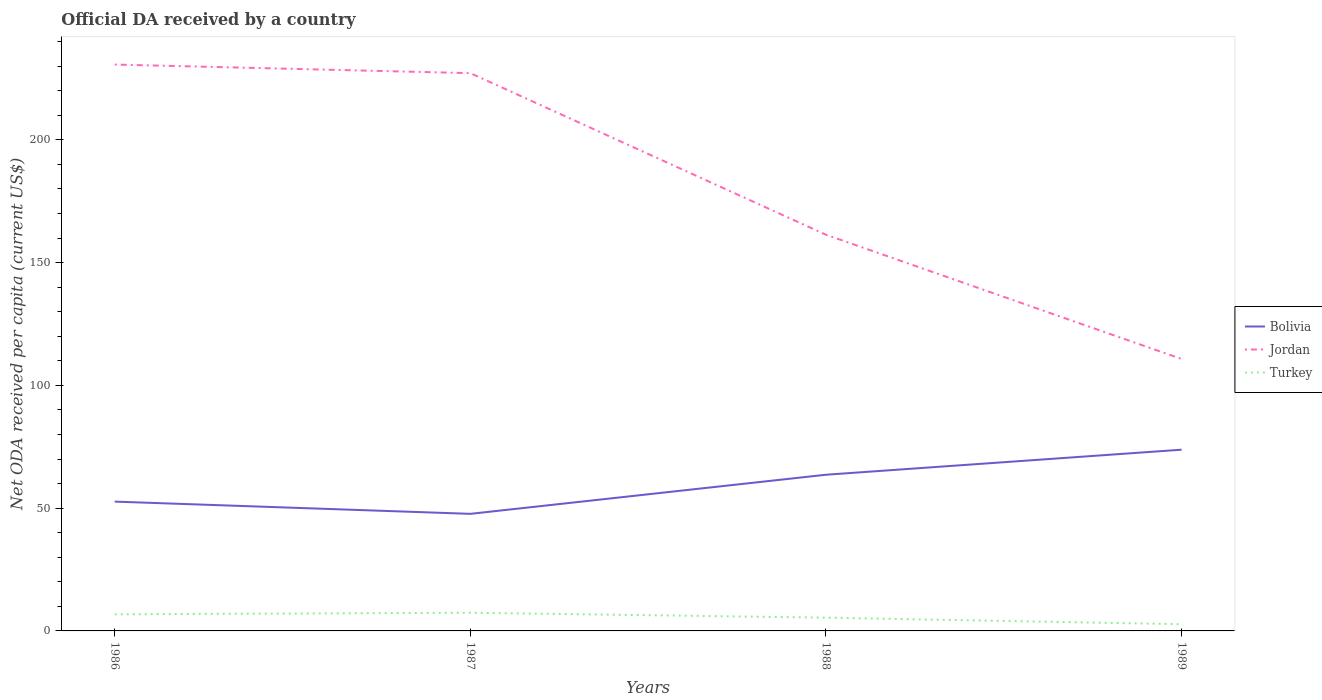Is the number of lines equal to the number of legend labels?
Offer a very short reply. Yes. Across all years, what is the maximum ODA received in in Turkey?
Offer a very short reply. 2.73. What is the total ODA received in in Bolivia in the graph?
Your answer should be compact. -26.13. What is the difference between the highest and the second highest ODA received in in Bolivia?
Provide a short and direct response. 26.13. What is the difference between the highest and the lowest ODA received in in Turkey?
Your answer should be compact. 2. How many years are there in the graph?
Keep it short and to the point. 4. What is the difference between two consecutive major ticks on the Y-axis?
Give a very brief answer. 50. Does the graph contain grids?
Give a very brief answer. No. Where does the legend appear in the graph?
Make the answer very short. Center right. How are the legend labels stacked?
Your answer should be very brief. Vertical. What is the title of the graph?
Offer a terse response. Official DA received by a country. What is the label or title of the Y-axis?
Your response must be concise. Net ODA received per capita (current US$). What is the Net ODA received per capita (current US$) of Bolivia in 1986?
Offer a very short reply. 52.66. What is the Net ODA received per capita (current US$) of Jordan in 1986?
Provide a succinct answer. 230.66. What is the Net ODA received per capita (current US$) of Turkey in 1986?
Make the answer very short. 6.77. What is the Net ODA received per capita (current US$) in Bolivia in 1987?
Offer a terse response. 47.68. What is the Net ODA received per capita (current US$) in Jordan in 1987?
Ensure brevity in your answer.  227.16. What is the Net ODA received per capita (current US$) in Turkey in 1987?
Ensure brevity in your answer.  7.4. What is the Net ODA received per capita (current US$) in Bolivia in 1988?
Offer a very short reply. 63.61. What is the Net ODA received per capita (current US$) in Jordan in 1988?
Offer a very short reply. 161.36. What is the Net ODA received per capita (current US$) in Turkey in 1988?
Provide a succinct answer. 5.41. What is the Net ODA received per capita (current US$) in Bolivia in 1989?
Make the answer very short. 73.81. What is the Net ODA received per capita (current US$) of Jordan in 1989?
Offer a terse response. 110.76. What is the Net ODA received per capita (current US$) in Turkey in 1989?
Provide a short and direct response. 2.73. Across all years, what is the maximum Net ODA received per capita (current US$) in Bolivia?
Provide a short and direct response. 73.81. Across all years, what is the maximum Net ODA received per capita (current US$) of Jordan?
Give a very brief answer. 230.66. Across all years, what is the maximum Net ODA received per capita (current US$) in Turkey?
Provide a short and direct response. 7.4. Across all years, what is the minimum Net ODA received per capita (current US$) of Bolivia?
Offer a very short reply. 47.68. Across all years, what is the minimum Net ODA received per capita (current US$) of Jordan?
Give a very brief answer. 110.76. Across all years, what is the minimum Net ODA received per capita (current US$) in Turkey?
Offer a very short reply. 2.73. What is the total Net ODA received per capita (current US$) in Bolivia in the graph?
Offer a terse response. 237.76. What is the total Net ODA received per capita (current US$) of Jordan in the graph?
Provide a succinct answer. 729.93. What is the total Net ODA received per capita (current US$) in Turkey in the graph?
Provide a succinct answer. 22.31. What is the difference between the Net ODA received per capita (current US$) of Bolivia in 1986 and that in 1987?
Ensure brevity in your answer.  4.98. What is the difference between the Net ODA received per capita (current US$) in Jordan in 1986 and that in 1987?
Ensure brevity in your answer.  3.5. What is the difference between the Net ODA received per capita (current US$) of Turkey in 1986 and that in 1987?
Offer a terse response. -0.63. What is the difference between the Net ODA received per capita (current US$) in Bolivia in 1986 and that in 1988?
Your answer should be very brief. -10.95. What is the difference between the Net ODA received per capita (current US$) in Jordan in 1986 and that in 1988?
Offer a very short reply. 69.3. What is the difference between the Net ODA received per capita (current US$) of Turkey in 1986 and that in 1988?
Your answer should be very brief. 1.37. What is the difference between the Net ODA received per capita (current US$) of Bolivia in 1986 and that in 1989?
Give a very brief answer. -21.15. What is the difference between the Net ODA received per capita (current US$) of Jordan in 1986 and that in 1989?
Give a very brief answer. 119.9. What is the difference between the Net ODA received per capita (current US$) of Turkey in 1986 and that in 1989?
Offer a terse response. 4.04. What is the difference between the Net ODA received per capita (current US$) in Bolivia in 1987 and that in 1988?
Give a very brief answer. -15.93. What is the difference between the Net ODA received per capita (current US$) in Jordan in 1987 and that in 1988?
Keep it short and to the point. 65.8. What is the difference between the Net ODA received per capita (current US$) in Turkey in 1987 and that in 1988?
Offer a terse response. 2. What is the difference between the Net ODA received per capita (current US$) in Bolivia in 1987 and that in 1989?
Provide a succinct answer. -26.13. What is the difference between the Net ODA received per capita (current US$) in Jordan in 1987 and that in 1989?
Ensure brevity in your answer.  116.4. What is the difference between the Net ODA received per capita (current US$) of Turkey in 1987 and that in 1989?
Offer a very short reply. 4.67. What is the difference between the Net ODA received per capita (current US$) in Bolivia in 1988 and that in 1989?
Provide a short and direct response. -10.2. What is the difference between the Net ODA received per capita (current US$) of Jordan in 1988 and that in 1989?
Make the answer very short. 50.6. What is the difference between the Net ODA received per capita (current US$) in Turkey in 1988 and that in 1989?
Keep it short and to the point. 2.67. What is the difference between the Net ODA received per capita (current US$) in Bolivia in 1986 and the Net ODA received per capita (current US$) in Jordan in 1987?
Your response must be concise. -174.49. What is the difference between the Net ODA received per capita (current US$) of Bolivia in 1986 and the Net ODA received per capita (current US$) of Turkey in 1987?
Your answer should be compact. 45.26. What is the difference between the Net ODA received per capita (current US$) of Jordan in 1986 and the Net ODA received per capita (current US$) of Turkey in 1987?
Provide a short and direct response. 223.25. What is the difference between the Net ODA received per capita (current US$) of Bolivia in 1986 and the Net ODA received per capita (current US$) of Jordan in 1988?
Offer a terse response. -108.69. What is the difference between the Net ODA received per capita (current US$) in Bolivia in 1986 and the Net ODA received per capita (current US$) in Turkey in 1988?
Provide a short and direct response. 47.26. What is the difference between the Net ODA received per capita (current US$) of Jordan in 1986 and the Net ODA received per capita (current US$) of Turkey in 1988?
Your answer should be very brief. 225.25. What is the difference between the Net ODA received per capita (current US$) in Bolivia in 1986 and the Net ODA received per capita (current US$) in Jordan in 1989?
Keep it short and to the point. -58.09. What is the difference between the Net ODA received per capita (current US$) of Bolivia in 1986 and the Net ODA received per capita (current US$) of Turkey in 1989?
Give a very brief answer. 49.93. What is the difference between the Net ODA received per capita (current US$) in Jordan in 1986 and the Net ODA received per capita (current US$) in Turkey in 1989?
Provide a succinct answer. 227.93. What is the difference between the Net ODA received per capita (current US$) in Bolivia in 1987 and the Net ODA received per capita (current US$) in Jordan in 1988?
Give a very brief answer. -113.68. What is the difference between the Net ODA received per capita (current US$) of Bolivia in 1987 and the Net ODA received per capita (current US$) of Turkey in 1988?
Make the answer very short. 42.27. What is the difference between the Net ODA received per capita (current US$) of Jordan in 1987 and the Net ODA received per capita (current US$) of Turkey in 1988?
Keep it short and to the point. 221.75. What is the difference between the Net ODA received per capita (current US$) of Bolivia in 1987 and the Net ODA received per capita (current US$) of Jordan in 1989?
Provide a succinct answer. -63.08. What is the difference between the Net ODA received per capita (current US$) in Bolivia in 1987 and the Net ODA received per capita (current US$) in Turkey in 1989?
Give a very brief answer. 44.95. What is the difference between the Net ODA received per capita (current US$) in Jordan in 1987 and the Net ODA received per capita (current US$) in Turkey in 1989?
Give a very brief answer. 224.43. What is the difference between the Net ODA received per capita (current US$) in Bolivia in 1988 and the Net ODA received per capita (current US$) in Jordan in 1989?
Your answer should be very brief. -47.15. What is the difference between the Net ODA received per capita (current US$) of Bolivia in 1988 and the Net ODA received per capita (current US$) of Turkey in 1989?
Your response must be concise. 60.88. What is the difference between the Net ODA received per capita (current US$) of Jordan in 1988 and the Net ODA received per capita (current US$) of Turkey in 1989?
Give a very brief answer. 158.63. What is the average Net ODA received per capita (current US$) in Bolivia per year?
Offer a terse response. 59.44. What is the average Net ODA received per capita (current US$) of Jordan per year?
Offer a terse response. 182.48. What is the average Net ODA received per capita (current US$) in Turkey per year?
Ensure brevity in your answer.  5.58. In the year 1986, what is the difference between the Net ODA received per capita (current US$) of Bolivia and Net ODA received per capita (current US$) of Jordan?
Offer a very short reply. -177.99. In the year 1986, what is the difference between the Net ODA received per capita (current US$) in Bolivia and Net ODA received per capita (current US$) in Turkey?
Give a very brief answer. 45.89. In the year 1986, what is the difference between the Net ODA received per capita (current US$) of Jordan and Net ODA received per capita (current US$) of Turkey?
Make the answer very short. 223.88. In the year 1987, what is the difference between the Net ODA received per capita (current US$) in Bolivia and Net ODA received per capita (current US$) in Jordan?
Make the answer very short. -179.48. In the year 1987, what is the difference between the Net ODA received per capita (current US$) of Bolivia and Net ODA received per capita (current US$) of Turkey?
Your answer should be compact. 40.28. In the year 1987, what is the difference between the Net ODA received per capita (current US$) in Jordan and Net ODA received per capita (current US$) in Turkey?
Your answer should be very brief. 219.75. In the year 1988, what is the difference between the Net ODA received per capita (current US$) in Bolivia and Net ODA received per capita (current US$) in Jordan?
Your answer should be very brief. -97.75. In the year 1988, what is the difference between the Net ODA received per capita (current US$) of Bolivia and Net ODA received per capita (current US$) of Turkey?
Ensure brevity in your answer.  58.2. In the year 1988, what is the difference between the Net ODA received per capita (current US$) in Jordan and Net ODA received per capita (current US$) in Turkey?
Give a very brief answer. 155.95. In the year 1989, what is the difference between the Net ODA received per capita (current US$) in Bolivia and Net ODA received per capita (current US$) in Jordan?
Your answer should be compact. -36.95. In the year 1989, what is the difference between the Net ODA received per capita (current US$) of Bolivia and Net ODA received per capita (current US$) of Turkey?
Provide a succinct answer. 71.08. In the year 1989, what is the difference between the Net ODA received per capita (current US$) of Jordan and Net ODA received per capita (current US$) of Turkey?
Your answer should be very brief. 108.03. What is the ratio of the Net ODA received per capita (current US$) of Bolivia in 1986 to that in 1987?
Keep it short and to the point. 1.1. What is the ratio of the Net ODA received per capita (current US$) of Jordan in 1986 to that in 1987?
Make the answer very short. 1.02. What is the ratio of the Net ODA received per capita (current US$) of Turkey in 1986 to that in 1987?
Your answer should be compact. 0.91. What is the ratio of the Net ODA received per capita (current US$) of Bolivia in 1986 to that in 1988?
Ensure brevity in your answer.  0.83. What is the ratio of the Net ODA received per capita (current US$) in Jordan in 1986 to that in 1988?
Your answer should be compact. 1.43. What is the ratio of the Net ODA received per capita (current US$) of Turkey in 1986 to that in 1988?
Your answer should be compact. 1.25. What is the ratio of the Net ODA received per capita (current US$) of Bolivia in 1986 to that in 1989?
Your response must be concise. 0.71. What is the ratio of the Net ODA received per capita (current US$) of Jordan in 1986 to that in 1989?
Your response must be concise. 2.08. What is the ratio of the Net ODA received per capita (current US$) of Turkey in 1986 to that in 1989?
Ensure brevity in your answer.  2.48. What is the ratio of the Net ODA received per capita (current US$) of Bolivia in 1987 to that in 1988?
Provide a succinct answer. 0.75. What is the ratio of the Net ODA received per capita (current US$) of Jordan in 1987 to that in 1988?
Your answer should be very brief. 1.41. What is the ratio of the Net ODA received per capita (current US$) of Turkey in 1987 to that in 1988?
Make the answer very short. 1.37. What is the ratio of the Net ODA received per capita (current US$) in Bolivia in 1987 to that in 1989?
Your response must be concise. 0.65. What is the ratio of the Net ODA received per capita (current US$) in Jordan in 1987 to that in 1989?
Ensure brevity in your answer.  2.05. What is the ratio of the Net ODA received per capita (current US$) in Turkey in 1987 to that in 1989?
Make the answer very short. 2.71. What is the ratio of the Net ODA received per capita (current US$) in Bolivia in 1988 to that in 1989?
Your answer should be very brief. 0.86. What is the ratio of the Net ODA received per capita (current US$) in Jordan in 1988 to that in 1989?
Provide a succinct answer. 1.46. What is the ratio of the Net ODA received per capita (current US$) of Turkey in 1988 to that in 1989?
Offer a terse response. 1.98. What is the difference between the highest and the second highest Net ODA received per capita (current US$) of Bolivia?
Your response must be concise. 10.2. What is the difference between the highest and the second highest Net ODA received per capita (current US$) of Jordan?
Give a very brief answer. 3.5. What is the difference between the highest and the second highest Net ODA received per capita (current US$) in Turkey?
Give a very brief answer. 0.63. What is the difference between the highest and the lowest Net ODA received per capita (current US$) in Bolivia?
Make the answer very short. 26.13. What is the difference between the highest and the lowest Net ODA received per capita (current US$) of Jordan?
Make the answer very short. 119.9. What is the difference between the highest and the lowest Net ODA received per capita (current US$) of Turkey?
Provide a short and direct response. 4.67. 